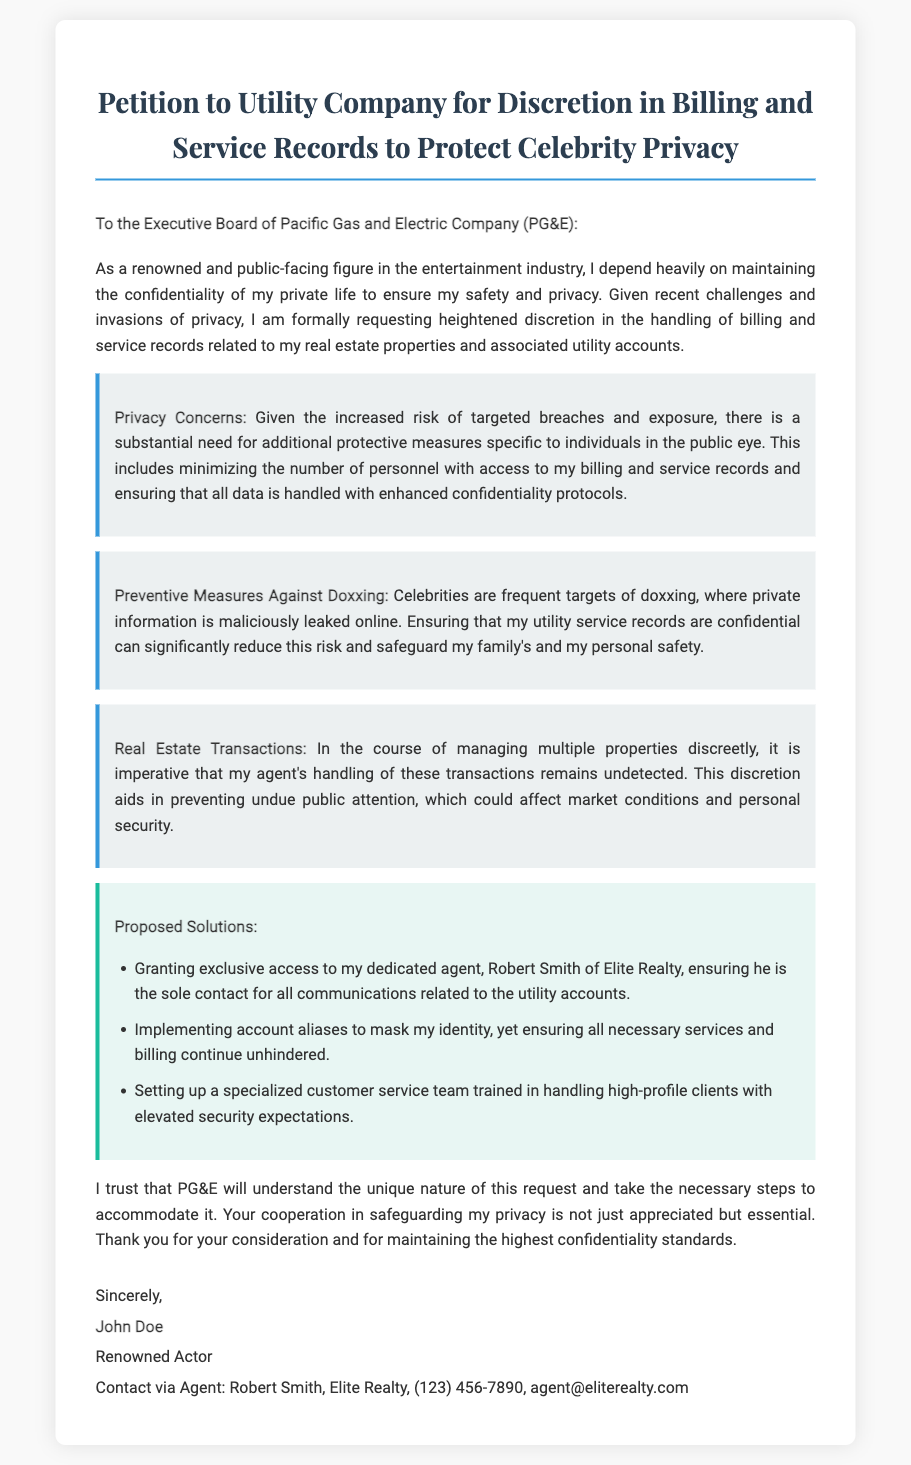What is the title of the document? The title is prominently displayed at the top of the document, stating the purpose of the request.
Answer: Petition to Utility Company for Discretion in Billing and Service Records to Protect Celebrity Privacy Who is the recipient of the petition? The salutation directly addresses the intended audience, identifying the utility company's executive board.
Answer: Executive Board of Pacific Gas and Electric Company (PG&E) What are the proposed solutions mentioned? The document lists specific solutions aimed at ensuring privacy, found within a designated section.
Answer: Granting exclusive access to my dedicated agent, implementing account aliases, setting up a specialized customer service team What concern is related to doxxing? The reasoning section highlights specific threats to personal privacy faced by public figures.
Answer: Celebrities are frequent targets of doxxing What is the name of the actor who signed the petition? The signature portion includes the name of the individual submitting the petition, confirming their identity.
Answer: John Doe 